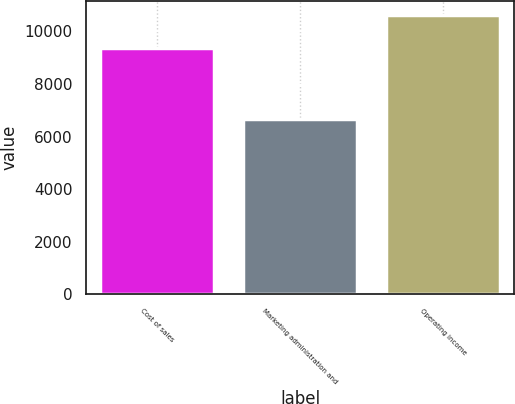Convert chart. <chart><loc_0><loc_0><loc_500><loc_500><bar_chart><fcel>Cost of sales<fcel>Marketing administration and<fcel>Operating income<nl><fcel>9365<fcel>6656<fcel>10623<nl></chart> 